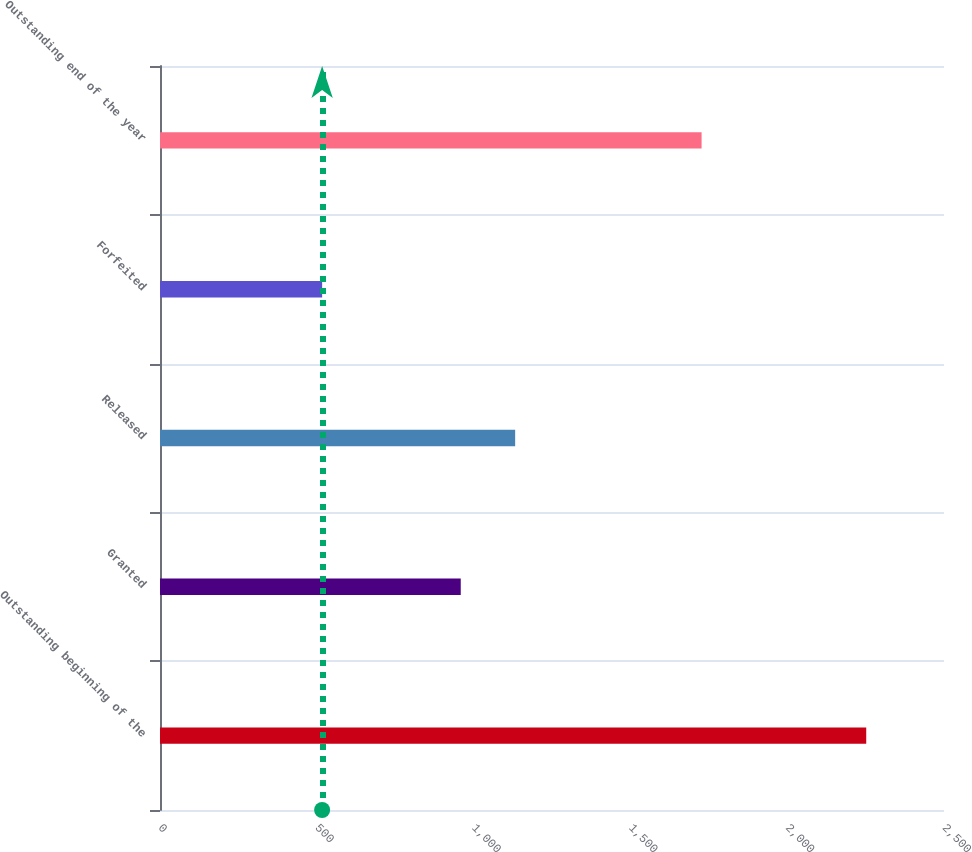Convert chart. <chart><loc_0><loc_0><loc_500><loc_500><bar_chart><fcel>Outstanding beginning of the<fcel>Granted<fcel>Released<fcel>Forfeited<fcel>Outstanding end of the year<nl><fcel>2252<fcel>959<fcel>1132.5<fcel>517<fcel>1727<nl></chart> 